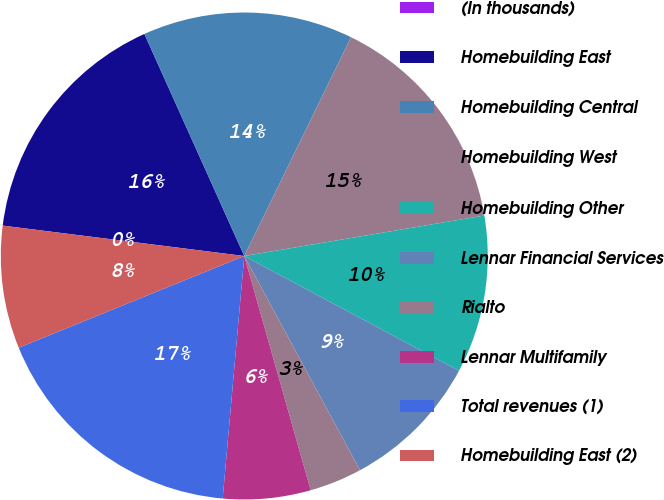Convert chart. <chart><loc_0><loc_0><loc_500><loc_500><pie_chart><fcel>(In thousands)<fcel>Homebuilding East<fcel>Homebuilding Central<fcel>Homebuilding West<fcel>Homebuilding Other<fcel>Lennar Financial Services<fcel>Rialto<fcel>Lennar Multifamily<fcel>Total revenues (1)<fcel>Homebuilding East (2)<nl><fcel>0.0%<fcel>16.28%<fcel>13.95%<fcel>15.12%<fcel>10.47%<fcel>9.3%<fcel>3.49%<fcel>5.81%<fcel>17.44%<fcel>8.14%<nl></chart> 